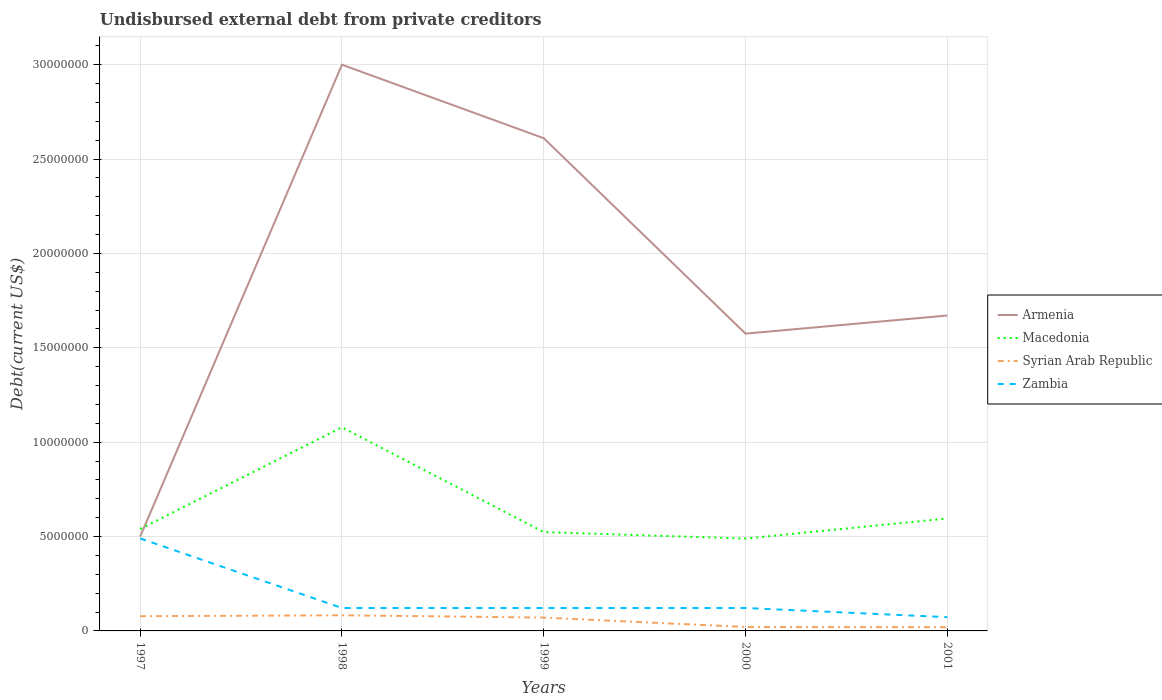Does the line corresponding to Armenia intersect with the line corresponding to Macedonia?
Your answer should be very brief. Yes. Across all years, what is the maximum total debt in Macedonia?
Keep it short and to the point. 4.89e+06. In which year was the total debt in Syrian Arab Republic maximum?
Make the answer very short. 2001. What is the total total debt in Syrian Arab Republic in the graph?
Ensure brevity in your answer.  1.10e+04. What is the difference between the highest and the second highest total debt in Armenia?
Make the answer very short. 2.50e+07. What is the difference between the highest and the lowest total debt in Zambia?
Make the answer very short. 1. Is the total debt in Zambia strictly greater than the total debt in Armenia over the years?
Offer a very short reply. Yes. How many years are there in the graph?
Keep it short and to the point. 5. What is the difference between two consecutive major ticks on the Y-axis?
Offer a very short reply. 5.00e+06. How many legend labels are there?
Ensure brevity in your answer.  4. How are the legend labels stacked?
Offer a terse response. Vertical. What is the title of the graph?
Your response must be concise. Undisbursed external debt from private creditors. Does "Germany" appear as one of the legend labels in the graph?
Keep it short and to the point. No. What is the label or title of the X-axis?
Give a very brief answer. Years. What is the label or title of the Y-axis?
Offer a terse response. Debt(current US$). What is the Debt(current US$) of Macedonia in 1997?
Provide a succinct answer. 5.40e+06. What is the Debt(current US$) in Syrian Arab Republic in 1997?
Ensure brevity in your answer.  7.80e+05. What is the Debt(current US$) in Zambia in 1997?
Offer a terse response. 4.90e+06. What is the Debt(current US$) in Armenia in 1998?
Your response must be concise. 3.00e+07. What is the Debt(current US$) in Macedonia in 1998?
Keep it short and to the point. 1.08e+07. What is the Debt(current US$) of Syrian Arab Republic in 1998?
Give a very brief answer. 8.30e+05. What is the Debt(current US$) of Zambia in 1998?
Your response must be concise. 1.21e+06. What is the Debt(current US$) in Armenia in 1999?
Your response must be concise. 2.61e+07. What is the Debt(current US$) in Macedonia in 1999?
Provide a short and direct response. 5.24e+06. What is the Debt(current US$) in Syrian Arab Republic in 1999?
Provide a succinct answer. 7.06e+05. What is the Debt(current US$) in Zambia in 1999?
Your answer should be very brief. 1.21e+06. What is the Debt(current US$) in Armenia in 2000?
Keep it short and to the point. 1.58e+07. What is the Debt(current US$) in Macedonia in 2000?
Provide a succinct answer. 4.89e+06. What is the Debt(current US$) of Syrian Arab Republic in 2000?
Your response must be concise. 2.09e+05. What is the Debt(current US$) in Zambia in 2000?
Keep it short and to the point. 1.21e+06. What is the Debt(current US$) of Armenia in 2001?
Offer a very short reply. 1.67e+07. What is the Debt(current US$) of Macedonia in 2001?
Offer a very short reply. 5.96e+06. What is the Debt(current US$) of Syrian Arab Republic in 2001?
Give a very brief answer. 1.98e+05. What is the Debt(current US$) in Zambia in 2001?
Offer a terse response. 7.28e+05. Across all years, what is the maximum Debt(current US$) of Armenia?
Offer a very short reply. 3.00e+07. Across all years, what is the maximum Debt(current US$) of Macedonia?
Offer a terse response. 1.08e+07. Across all years, what is the maximum Debt(current US$) of Syrian Arab Republic?
Your answer should be very brief. 8.30e+05. Across all years, what is the maximum Debt(current US$) of Zambia?
Your response must be concise. 4.90e+06. Across all years, what is the minimum Debt(current US$) of Macedonia?
Offer a very short reply. 4.89e+06. Across all years, what is the minimum Debt(current US$) in Syrian Arab Republic?
Provide a short and direct response. 1.98e+05. Across all years, what is the minimum Debt(current US$) in Zambia?
Give a very brief answer. 7.28e+05. What is the total Debt(current US$) in Armenia in the graph?
Your answer should be compact. 9.36e+07. What is the total Debt(current US$) in Macedonia in the graph?
Keep it short and to the point. 3.23e+07. What is the total Debt(current US$) in Syrian Arab Republic in the graph?
Offer a very short reply. 2.72e+06. What is the total Debt(current US$) of Zambia in the graph?
Make the answer very short. 9.27e+06. What is the difference between the Debt(current US$) of Armenia in 1997 and that in 1998?
Your answer should be compact. -2.50e+07. What is the difference between the Debt(current US$) of Macedonia in 1997 and that in 1998?
Offer a terse response. -5.38e+06. What is the difference between the Debt(current US$) in Zambia in 1997 and that in 1998?
Make the answer very short. 3.69e+06. What is the difference between the Debt(current US$) of Armenia in 1997 and that in 1999?
Keep it short and to the point. -2.11e+07. What is the difference between the Debt(current US$) in Macedonia in 1997 and that in 1999?
Keep it short and to the point. 1.67e+05. What is the difference between the Debt(current US$) in Syrian Arab Republic in 1997 and that in 1999?
Provide a short and direct response. 7.40e+04. What is the difference between the Debt(current US$) of Zambia in 1997 and that in 1999?
Keep it short and to the point. 3.69e+06. What is the difference between the Debt(current US$) of Armenia in 1997 and that in 2000?
Your answer should be compact. -1.08e+07. What is the difference between the Debt(current US$) in Macedonia in 1997 and that in 2000?
Offer a terse response. 5.09e+05. What is the difference between the Debt(current US$) of Syrian Arab Republic in 1997 and that in 2000?
Offer a terse response. 5.71e+05. What is the difference between the Debt(current US$) in Zambia in 1997 and that in 2000?
Ensure brevity in your answer.  3.69e+06. What is the difference between the Debt(current US$) in Armenia in 1997 and that in 2001?
Your answer should be very brief. -1.17e+07. What is the difference between the Debt(current US$) in Macedonia in 1997 and that in 2001?
Provide a succinct answer. -5.55e+05. What is the difference between the Debt(current US$) in Syrian Arab Republic in 1997 and that in 2001?
Offer a terse response. 5.82e+05. What is the difference between the Debt(current US$) in Zambia in 1997 and that in 2001?
Provide a succinct answer. 4.17e+06. What is the difference between the Debt(current US$) in Armenia in 1998 and that in 1999?
Ensure brevity in your answer.  3.90e+06. What is the difference between the Debt(current US$) in Macedonia in 1998 and that in 1999?
Ensure brevity in your answer.  5.55e+06. What is the difference between the Debt(current US$) in Syrian Arab Republic in 1998 and that in 1999?
Offer a very short reply. 1.24e+05. What is the difference between the Debt(current US$) in Armenia in 1998 and that in 2000?
Provide a short and direct response. 1.42e+07. What is the difference between the Debt(current US$) in Macedonia in 1998 and that in 2000?
Your answer should be very brief. 5.89e+06. What is the difference between the Debt(current US$) in Syrian Arab Republic in 1998 and that in 2000?
Make the answer very short. 6.21e+05. What is the difference between the Debt(current US$) of Zambia in 1998 and that in 2000?
Offer a terse response. 0. What is the difference between the Debt(current US$) of Armenia in 1998 and that in 2001?
Ensure brevity in your answer.  1.33e+07. What is the difference between the Debt(current US$) of Macedonia in 1998 and that in 2001?
Make the answer very short. 4.83e+06. What is the difference between the Debt(current US$) in Syrian Arab Republic in 1998 and that in 2001?
Offer a terse response. 6.32e+05. What is the difference between the Debt(current US$) of Zambia in 1998 and that in 2001?
Offer a terse response. 4.86e+05. What is the difference between the Debt(current US$) in Armenia in 1999 and that in 2000?
Ensure brevity in your answer.  1.04e+07. What is the difference between the Debt(current US$) in Macedonia in 1999 and that in 2000?
Ensure brevity in your answer.  3.42e+05. What is the difference between the Debt(current US$) in Syrian Arab Republic in 1999 and that in 2000?
Give a very brief answer. 4.97e+05. What is the difference between the Debt(current US$) of Zambia in 1999 and that in 2000?
Provide a short and direct response. 0. What is the difference between the Debt(current US$) in Armenia in 1999 and that in 2001?
Offer a very short reply. 9.39e+06. What is the difference between the Debt(current US$) of Macedonia in 1999 and that in 2001?
Give a very brief answer. -7.22e+05. What is the difference between the Debt(current US$) of Syrian Arab Republic in 1999 and that in 2001?
Your response must be concise. 5.08e+05. What is the difference between the Debt(current US$) in Zambia in 1999 and that in 2001?
Provide a short and direct response. 4.86e+05. What is the difference between the Debt(current US$) of Armenia in 2000 and that in 2001?
Give a very brief answer. -9.60e+05. What is the difference between the Debt(current US$) of Macedonia in 2000 and that in 2001?
Make the answer very short. -1.06e+06. What is the difference between the Debt(current US$) of Syrian Arab Republic in 2000 and that in 2001?
Provide a short and direct response. 1.10e+04. What is the difference between the Debt(current US$) of Zambia in 2000 and that in 2001?
Provide a short and direct response. 4.86e+05. What is the difference between the Debt(current US$) of Armenia in 1997 and the Debt(current US$) of Macedonia in 1998?
Your answer should be very brief. -5.79e+06. What is the difference between the Debt(current US$) of Armenia in 1997 and the Debt(current US$) of Syrian Arab Republic in 1998?
Your answer should be very brief. 4.17e+06. What is the difference between the Debt(current US$) in Armenia in 1997 and the Debt(current US$) in Zambia in 1998?
Offer a very short reply. 3.79e+06. What is the difference between the Debt(current US$) of Macedonia in 1997 and the Debt(current US$) of Syrian Arab Republic in 1998?
Ensure brevity in your answer.  4.57e+06. What is the difference between the Debt(current US$) in Macedonia in 1997 and the Debt(current US$) in Zambia in 1998?
Offer a very short reply. 4.19e+06. What is the difference between the Debt(current US$) of Syrian Arab Republic in 1997 and the Debt(current US$) of Zambia in 1998?
Your answer should be very brief. -4.34e+05. What is the difference between the Debt(current US$) in Armenia in 1997 and the Debt(current US$) in Macedonia in 1999?
Make the answer very short. -2.36e+05. What is the difference between the Debt(current US$) of Armenia in 1997 and the Debt(current US$) of Syrian Arab Republic in 1999?
Your answer should be very brief. 4.29e+06. What is the difference between the Debt(current US$) of Armenia in 1997 and the Debt(current US$) of Zambia in 1999?
Offer a terse response. 3.79e+06. What is the difference between the Debt(current US$) in Macedonia in 1997 and the Debt(current US$) in Syrian Arab Republic in 1999?
Keep it short and to the point. 4.70e+06. What is the difference between the Debt(current US$) in Macedonia in 1997 and the Debt(current US$) in Zambia in 1999?
Provide a short and direct response. 4.19e+06. What is the difference between the Debt(current US$) in Syrian Arab Republic in 1997 and the Debt(current US$) in Zambia in 1999?
Your answer should be compact. -4.34e+05. What is the difference between the Debt(current US$) of Armenia in 1997 and the Debt(current US$) of Macedonia in 2000?
Give a very brief answer. 1.06e+05. What is the difference between the Debt(current US$) in Armenia in 1997 and the Debt(current US$) in Syrian Arab Republic in 2000?
Your answer should be compact. 4.79e+06. What is the difference between the Debt(current US$) of Armenia in 1997 and the Debt(current US$) of Zambia in 2000?
Offer a very short reply. 3.79e+06. What is the difference between the Debt(current US$) of Macedonia in 1997 and the Debt(current US$) of Syrian Arab Republic in 2000?
Offer a very short reply. 5.19e+06. What is the difference between the Debt(current US$) of Macedonia in 1997 and the Debt(current US$) of Zambia in 2000?
Your response must be concise. 4.19e+06. What is the difference between the Debt(current US$) of Syrian Arab Republic in 1997 and the Debt(current US$) of Zambia in 2000?
Your response must be concise. -4.34e+05. What is the difference between the Debt(current US$) in Armenia in 1997 and the Debt(current US$) in Macedonia in 2001?
Your response must be concise. -9.58e+05. What is the difference between the Debt(current US$) of Armenia in 1997 and the Debt(current US$) of Syrian Arab Republic in 2001?
Your answer should be very brief. 4.80e+06. What is the difference between the Debt(current US$) of Armenia in 1997 and the Debt(current US$) of Zambia in 2001?
Provide a succinct answer. 4.27e+06. What is the difference between the Debt(current US$) of Macedonia in 1997 and the Debt(current US$) of Syrian Arab Republic in 2001?
Provide a succinct answer. 5.20e+06. What is the difference between the Debt(current US$) of Macedonia in 1997 and the Debt(current US$) of Zambia in 2001?
Provide a short and direct response. 4.68e+06. What is the difference between the Debt(current US$) of Syrian Arab Republic in 1997 and the Debt(current US$) of Zambia in 2001?
Provide a short and direct response. 5.20e+04. What is the difference between the Debt(current US$) of Armenia in 1998 and the Debt(current US$) of Macedonia in 1999?
Ensure brevity in your answer.  2.48e+07. What is the difference between the Debt(current US$) of Armenia in 1998 and the Debt(current US$) of Syrian Arab Republic in 1999?
Keep it short and to the point. 2.93e+07. What is the difference between the Debt(current US$) in Armenia in 1998 and the Debt(current US$) in Zambia in 1999?
Provide a short and direct response. 2.88e+07. What is the difference between the Debt(current US$) of Macedonia in 1998 and the Debt(current US$) of Syrian Arab Republic in 1999?
Your response must be concise. 1.01e+07. What is the difference between the Debt(current US$) in Macedonia in 1998 and the Debt(current US$) in Zambia in 1999?
Offer a terse response. 9.57e+06. What is the difference between the Debt(current US$) of Syrian Arab Republic in 1998 and the Debt(current US$) of Zambia in 1999?
Offer a very short reply. -3.84e+05. What is the difference between the Debt(current US$) in Armenia in 1998 and the Debt(current US$) in Macedonia in 2000?
Your response must be concise. 2.51e+07. What is the difference between the Debt(current US$) of Armenia in 1998 and the Debt(current US$) of Syrian Arab Republic in 2000?
Your answer should be compact. 2.98e+07. What is the difference between the Debt(current US$) of Armenia in 1998 and the Debt(current US$) of Zambia in 2000?
Your answer should be compact. 2.88e+07. What is the difference between the Debt(current US$) of Macedonia in 1998 and the Debt(current US$) of Syrian Arab Republic in 2000?
Provide a short and direct response. 1.06e+07. What is the difference between the Debt(current US$) in Macedonia in 1998 and the Debt(current US$) in Zambia in 2000?
Provide a succinct answer. 9.57e+06. What is the difference between the Debt(current US$) of Syrian Arab Republic in 1998 and the Debt(current US$) of Zambia in 2000?
Offer a very short reply. -3.84e+05. What is the difference between the Debt(current US$) of Armenia in 1998 and the Debt(current US$) of Macedonia in 2001?
Keep it short and to the point. 2.40e+07. What is the difference between the Debt(current US$) of Armenia in 1998 and the Debt(current US$) of Syrian Arab Republic in 2001?
Give a very brief answer. 2.98e+07. What is the difference between the Debt(current US$) of Armenia in 1998 and the Debt(current US$) of Zambia in 2001?
Make the answer very short. 2.93e+07. What is the difference between the Debt(current US$) of Macedonia in 1998 and the Debt(current US$) of Syrian Arab Republic in 2001?
Make the answer very short. 1.06e+07. What is the difference between the Debt(current US$) in Macedonia in 1998 and the Debt(current US$) in Zambia in 2001?
Your answer should be compact. 1.01e+07. What is the difference between the Debt(current US$) of Syrian Arab Republic in 1998 and the Debt(current US$) of Zambia in 2001?
Make the answer very short. 1.02e+05. What is the difference between the Debt(current US$) in Armenia in 1999 and the Debt(current US$) in Macedonia in 2000?
Offer a terse response. 2.12e+07. What is the difference between the Debt(current US$) of Armenia in 1999 and the Debt(current US$) of Syrian Arab Republic in 2000?
Your response must be concise. 2.59e+07. What is the difference between the Debt(current US$) in Armenia in 1999 and the Debt(current US$) in Zambia in 2000?
Give a very brief answer. 2.49e+07. What is the difference between the Debt(current US$) of Macedonia in 1999 and the Debt(current US$) of Syrian Arab Republic in 2000?
Keep it short and to the point. 5.03e+06. What is the difference between the Debt(current US$) of Macedonia in 1999 and the Debt(current US$) of Zambia in 2000?
Provide a short and direct response. 4.02e+06. What is the difference between the Debt(current US$) of Syrian Arab Republic in 1999 and the Debt(current US$) of Zambia in 2000?
Make the answer very short. -5.08e+05. What is the difference between the Debt(current US$) of Armenia in 1999 and the Debt(current US$) of Macedonia in 2001?
Provide a succinct answer. 2.01e+07. What is the difference between the Debt(current US$) in Armenia in 1999 and the Debt(current US$) in Syrian Arab Republic in 2001?
Make the answer very short. 2.59e+07. What is the difference between the Debt(current US$) of Armenia in 1999 and the Debt(current US$) of Zambia in 2001?
Keep it short and to the point. 2.54e+07. What is the difference between the Debt(current US$) in Macedonia in 1999 and the Debt(current US$) in Syrian Arab Republic in 2001?
Ensure brevity in your answer.  5.04e+06. What is the difference between the Debt(current US$) of Macedonia in 1999 and the Debt(current US$) of Zambia in 2001?
Provide a succinct answer. 4.51e+06. What is the difference between the Debt(current US$) of Syrian Arab Republic in 1999 and the Debt(current US$) of Zambia in 2001?
Your response must be concise. -2.20e+04. What is the difference between the Debt(current US$) of Armenia in 2000 and the Debt(current US$) of Macedonia in 2001?
Your answer should be compact. 9.79e+06. What is the difference between the Debt(current US$) in Armenia in 2000 and the Debt(current US$) in Syrian Arab Republic in 2001?
Provide a short and direct response. 1.56e+07. What is the difference between the Debt(current US$) in Armenia in 2000 and the Debt(current US$) in Zambia in 2001?
Offer a very short reply. 1.50e+07. What is the difference between the Debt(current US$) in Macedonia in 2000 and the Debt(current US$) in Syrian Arab Republic in 2001?
Offer a terse response. 4.70e+06. What is the difference between the Debt(current US$) of Macedonia in 2000 and the Debt(current US$) of Zambia in 2001?
Give a very brief answer. 4.17e+06. What is the difference between the Debt(current US$) of Syrian Arab Republic in 2000 and the Debt(current US$) of Zambia in 2001?
Give a very brief answer. -5.19e+05. What is the average Debt(current US$) of Armenia per year?
Make the answer very short. 1.87e+07. What is the average Debt(current US$) of Macedonia per year?
Provide a short and direct response. 6.46e+06. What is the average Debt(current US$) in Syrian Arab Republic per year?
Make the answer very short. 5.45e+05. What is the average Debt(current US$) in Zambia per year?
Provide a succinct answer. 1.85e+06. In the year 1997, what is the difference between the Debt(current US$) of Armenia and Debt(current US$) of Macedonia?
Your answer should be very brief. -4.03e+05. In the year 1997, what is the difference between the Debt(current US$) in Armenia and Debt(current US$) in Syrian Arab Republic?
Give a very brief answer. 4.22e+06. In the year 1997, what is the difference between the Debt(current US$) in Armenia and Debt(current US$) in Zambia?
Give a very brief answer. 1.00e+05. In the year 1997, what is the difference between the Debt(current US$) of Macedonia and Debt(current US$) of Syrian Arab Republic?
Give a very brief answer. 4.62e+06. In the year 1997, what is the difference between the Debt(current US$) in Macedonia and Debt(current US$) in Zambia?
Keep it short and to the point. 5.03e+05. In the year 1997, what is the difference between the Debt(current US$) in Syrian Arab Republic and Debt(current US$) in Zambia?
Your response must be concise. -4.12e+06. In the year 1998, what is the difference between the Debt(current US$) in Armenia and Debt(current US$) in Macedonia?
Your response must be concise. 1.92e+07. In the year 1998, what is the difference between the Debt(current US$) of Armenia and Debt(current US$) of Syrian Arab Republic?
Provide a short and direct response. 2.92e+07. In the year 1998, what is the difference between the Debt(current US$) of Armenia and Debt(current US$) of Zambia?
Provide a succinct answer. 2.88e+07. In the year 1998, what is the difference between the Debt(current US$) in Macedonia and Debt(current US$) in Syrian Arab Republic?
Your response must be concise. 9.96e+06. In the year 1998, what is the difference between the Debt(current US$) of Macedonia and Debt(current US$) of Zambia?
Make the answer very short. 9.57e+06. In the year 1998, what is the difference between the Debt(current US$) in Syrian Arab Republic and Debt(current US$) in Zambia?
Make the answer very short. -3.84e+05. In the year 1999, what is the difference between the Debt(current US$) in Armenia and Debt(current US$) in Macedonia?
Make the answer very short. 2.09e+07. In the year 1999, what is the difference between the Debt(current US$) in Armenia and Debt(current US$) in Syrian Arab Republic?
Ensure brevity in your answer.  2.54e+07. In the year 1999, what is the difference between the Debt(current US$) of Armenia and Debt(current US$) of Zambia?
Provide a short and direct response. 2.49e+07. In the year 1999, what is the difference between the Debt(current US$) in Macedonia and Debt(current US$) in Syrian Arab Republic?
Offer a terse response. 4.53e+06. In the year 1999, what is the difference between the Debt(current US$) of Macedonia and Debt(current US$) of Zambia?
Give a very brief answer. 4.02e+06. In the year 1999, what is the difference between the Debt(current US$) in Syrian Arab Republic and Debt(current US$) in Zambia?
Your answer should be compact. -5.08e+05. In the year 2000, what is the difference between the Debt(current US$) of Armenia and Debt(current US$) of Macedonia?
Your response must be concise. 1.09e+07. In the year 2000, what is the difference between the Debt(current US$) of Armenia and Debt(current US$) of Syrian Arab Republic?
Provide a short and direct response. 1.55e+07. In the year 2000, what is the difference between the Debt(current US$) in Armenia and Debt(current US$) in Zambia?
Offer a very short reply. 1.45e+07. In the year 2000, what is the difference between the Debt(current US$) of Macedonia and Debt(current US$) of Syrian Arab Republic?
Your response must be concise. 4.68e+06. In the year 2000, what is the difference between the Debt(current US$) of Macedonia and Debt(current US$) of Zambia?
Give a very brief answer. 3.68e+06. In the year 2000, what is the difference between the Debt(current US$) of Syrian Arab Republic and Debt(current US$) of Zambia?
Your answer should be compact. -1.00e+06. In the year 2001, what is the difference between the Debt(current US$) of Armenia and Debt(current US$) of Macedonia?
Your response must be concise. 1.08e+07. In the year 2001, what is the difference between the Debt(current US$) in Armenia and Debt(current US$) in Syrian Arab Republic?
Offer a very short reply. 1.65e+07. In the year 2001, what is the difference between the Debt(current US$) of Armenia and Debt(current US$) of Zambia?
Ensure brevity in your answer.  1.60e+07. In the year 2001, what is the difference between the Debt(current US$) in Macedonia and Debt(current US$) in Syrian Arab Republic?
Your answer should be compact. 5.76e+06. In the year 2001, what is the difference between the Debt(current US$) in Macedonia and Debt(current US$) in Zambia?
Your answer should be compact. 5.23e+06. In the year 2001, what is the difference between the Debt(current US$) of Syrian Arab Republic and Debt(current US$) of Zambia?
Make the answer very short. -5.30e+05. What is the ratio of the Debt(current US$) in Armenia in 1997 to that in 1998?
Provide a short and direct response. 0.17. What is the ratio of the Debt(current US$) of Macedonia in 1997 to that in 1998?
Your answer should be compact. 0.5. What is the ratio of the Debt(current US$) in Syrian Arab Republic in 1997 to that in 1998?
Offer a very short reply. 0.94. What is the ratio of the Debt(current US$) in Zambia in 1997 to that in 1998?
Give a very brief answer. 4.04. What is the ratio of the Debt(current US$) of Armenia in 1997 to that in 1999?
Offer a terse response. 0.19. What is the ratio of the Debt(current US$) in Macedonia in 1997 to that in 1999?
Make the answer very short. 1.03. What is the ratio of the Debt(current US$) in Syrian Arab Republic in 1997 to that in 1999?
Provide a short and direct response. 1.1. What is the ratio of the Debt(current US$) of Zambia in 1997 to that in 1999?
Make the answer very short. 4.04. What is the ratio of the Debt(current US$) in Armenia in 1997 to that in 2000?
Provide a short and direct response. 0.32. What is the ratio of the Debt(current US$) in Macedonia in 1997 to that in 2000?
Your response must be concise. 1.1. What is the ratio of the Debt(current US$) in Syrian Arab Republic in 1997 to that in 2000?
Give a very brief answer. 3.73. What is the ratio of the Debt(current US$) in Zambia in 1997 to that in 2000?
Give a very brief answer. 4.04. What is the ratio of the Debt(current US$) of Armenia in 1997 to that in 2001?
Your answer should be compact. 0.3. What is the ratio of the Debt(current US$) of Macedonia in 1997 to that in 2001?
Your answer should be very brief. 0.91. What is the ratio of the Debt(current US$) of Syrian Arab Republic in 1997 to that in 2001?
Make the answer very short. 3.94. What is the ratio of the Debt(current US$) in Zambia in 1997 to that in 2001?
Offer a terse response. 6.73. What is the ratio of the Debt(current US$) of Armenia in 1998 to that in 1999?
Your answer should be very brief. 1.15. What is the ratio of the Debt(current US$) of Macedonia in 1998 to that in 1999?
Provide a short and direct response. 2.06. What is the ratio of the Debt(current US$) in Syrian Arab Republic in 1998 to that in 1999?
Provide a short and direct response. 1.18. What is the ratio of the Debt(current US$) in Zambia in 1998 to that in 1999?
Your answer should be very brief. 1. What is the ratio of the Debt(current US$) of Armenia in 1998 to that in 2000?
Provide a short and direct response. 1.9. What is the ratio of the Debt(current US$) of Macedonia in 1998 to that in 2000?
Give a very brief answer. 2.2. What is the ratio of the Debt(current US$) in Syrian Arab Republic in 1998 to that in 2000?
Offer a terse response. 3.97. What is the ratio of the Debt(current US$) in Armenia in 1998 to that in 2001?
Your answer should be compact. 1.8. What is the ratio of the Debt(current US$) of Macedonia in 1998 to that in 2001?
Your answer should be very brief. 1.81. What is the ratio of the Debt(current US$) in Syrian Arab Republic in 1998 to that in 2001?
Offer a very short reply. 4.19. What is the ratio of the Debt(current US$) of Zambia in 1998 to that in 2001?
Make the answer very short. 1.67. What is the ratio of the Debt(current US$) of Armenia in 1999 to that in 2000?
Keep it short and to the point. 1.66. What is the ratio of the Debt(current US$) of Macedonia in 1999 to that in 2000?
Offer a terse response. 1.07. What is the ratio of the Debt(current US$) in Syrian Arab Republic in 1999 to that in 2000?
Provide a succinct answer. 3.38. What is the ratio of the Debt(current US$) of Armenia in 1999 to that in 2001?
Offer a very short reply. 1.56. What is the ratio of the Debt(current US$) of Macedonia in 1999 to that in 2001?
Your answer should be very brief. 0.88. What is the ratio of the Debt(current US$) of Syrian Arab Republic in 1999 to that in 2001?
Give a very brief answer. 3.57. What is the ratio of the Debt(current US$) of Zambia in 1999 to that in 2001?
Provide a short and direct response. 1.67. What is the ratio of the Debt(current US$) of Armenia in 2000 to that in 2001?
Make the answer very short. 0.94. What is the ratio of the Debt(current US$) of Macedonia in 2000 to that in 2001?
Provide a succinct answer. 0.82. What is the ratio of the Debt(current US$) of Syrian Arab Republic in 2000 to that in 2001?
Provide a succinct answer. 1.06. What is the ratio of the Debt(current US$) in Zambia in 2000 to that in 2001?
Offer a terse response. 1.67. What is the difference between the highest and the second highest Debt(current US$) of Armenia?
Your answer should be very brief. 3.90e+06. What is the difference between the highest and the second highest Debt(current US$) in Macedonia?
Your answer should be very brief. 4.83e+06. What is the difference between the highest and the second highest Debt(current US$) of Zambia?
Keep it short and to the point. 3.69e+06. What is the difference between the highest and the lowest Debt(current US$) in Armenia?
Give a very brief answer. 2.50e+07. What is the difference between the highest and the lowest Debt(current US$) of Macedonia?
Offer a terse response. 5.89e+06. What is the difference between the highest and the lowest Debt(current US$) of Syrian Arab Republic?
Offer a terse response. 6.32e+05. What is the difference between the highest and the lowest Debt(current US$) of Zambia?
Provide a short and direct response. 4.17e+06. 